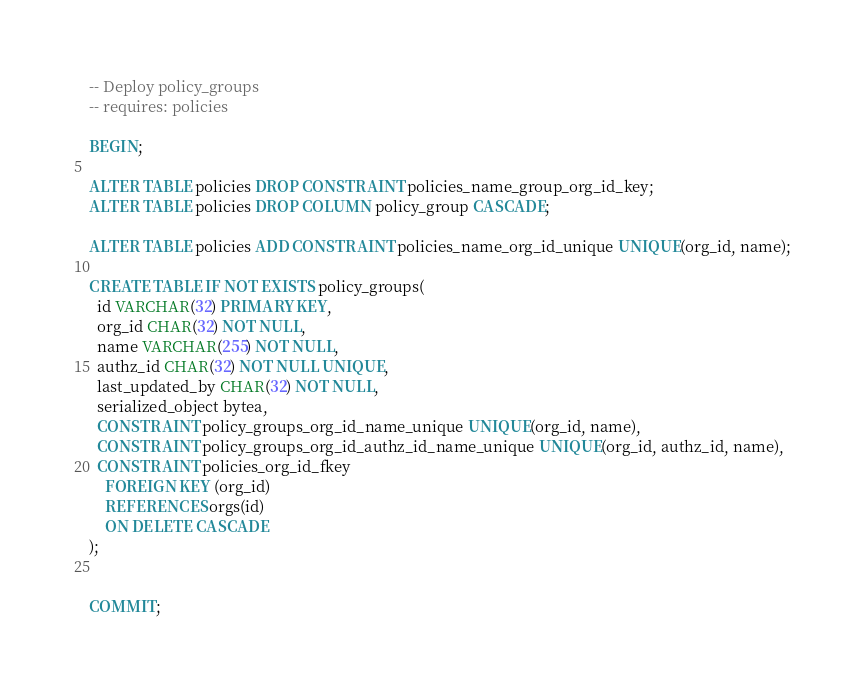Convert code to text. <code><loc_0><loc_0><loc_500><loc_500><_SQL_>-- Deploy policy_groups
-- requires: policies

BEGIN;

ALTER TABLE policies DROP CONSTRAINT policies_name_group_org_id_key;
ALTER TABLE policies DROP COLUMN policy_group CASCADE;

ALTER TABLE policies ADD CONSTRAINT policies_name_org_id_unique UNIQUE(org_id, name);

CREATE TABLE IF NOT EXISTS policy_groups(
  id VARCHAR(32) PRIMARY KEY,
  org_id CHAR(32) NOT NULL,
  name VARCHAR(255) NOT NULL,
  authz_id CHAR(32) NOT NULL UNIQUE,
  last_updated_by CHAR(32) NOT NULL,
  serialized_object bytea,
  CONSTRAINT policy_groups_org_id_name_unique UNIQUE(org_id, name),
  CONSTRAINT policy_groups_org_id_authz_id_name_unique UNIQUE(org_id, authz_id, name),
  CONSTRAINT policies_org_id_fkey
    FOREIGN KEY (org_id)
    REFERENCES orgs(id)
    ON DELETE CASCADE
);


COMMIT;
</code> 